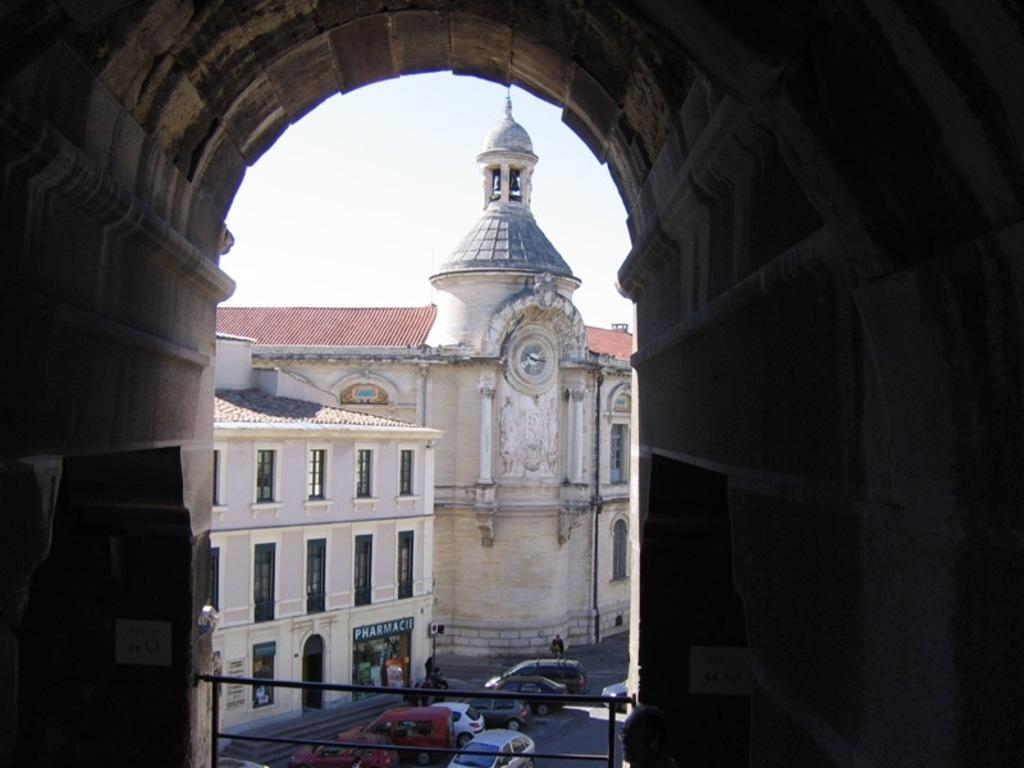In one or two sentences, can you explain what this image depicts? As we can see in the image there are buildings, windows, cars, clock and a sky. 